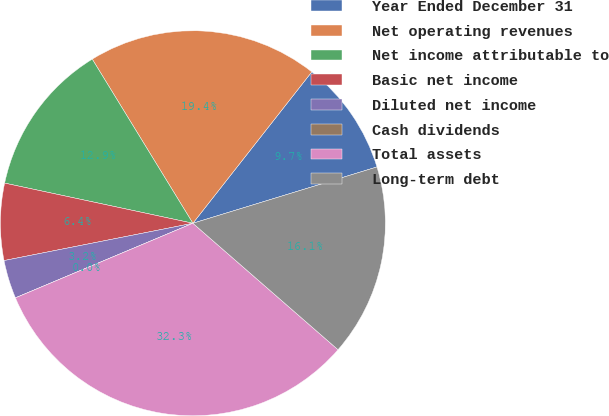<chart> <loc_0><loc_0><loc_500><loc_500><pie_chart><fcel>Year Ended December 31<fcel>Net operating revenues<fcel>Net income attributable to<fcel>Basic net income<fcel>Diluted net income<fcel>Cash dividends<fcel>Total assets<fcel>Long-term debt<nl><fcel>9.68%<fcel>19.35%<fcel>12.9%<fcel>6.45%<fcel>3.23%<fcel>0.0%<fcel>32.26%<fcel>16.13%<nl></chart> 